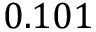<formula> <loc_0><loc_0><loc_500><loc_500>0 . 1 0 1</formula> 